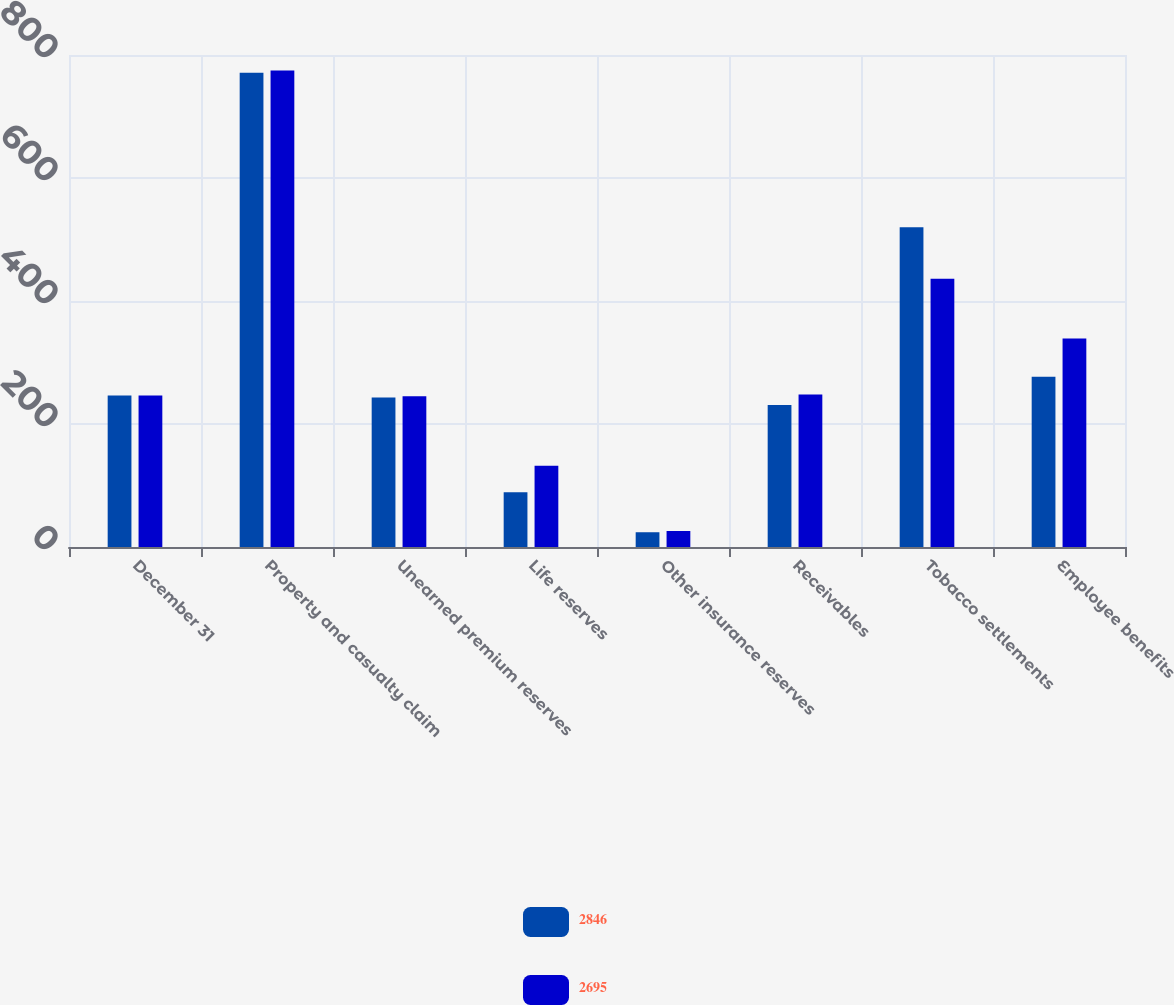<chart> <loc_0><loc_0><loc_500><loc_500><stacked_bar_chart><ecel><fcel>December 31<fcel>Property and casualty claim<fcel>Unearned premium reserves<fcel>Life reserves<fcel>Other insurance reserves<fcel>Receivables<fcel>Tobacco settlements<fcel>Employee benefits<nl><fcel>2846<fcel>246.5<fcel>771<fcel>243<fcel>89<fcel>24<fcel>231<fcel>520<fcel>277<nl><fcel>2695<fcel>246.5<fcel>775<fcel>245<fcel>132<fcel>26<fcel>248<fcel>436<fcel>339<nl></chart> 